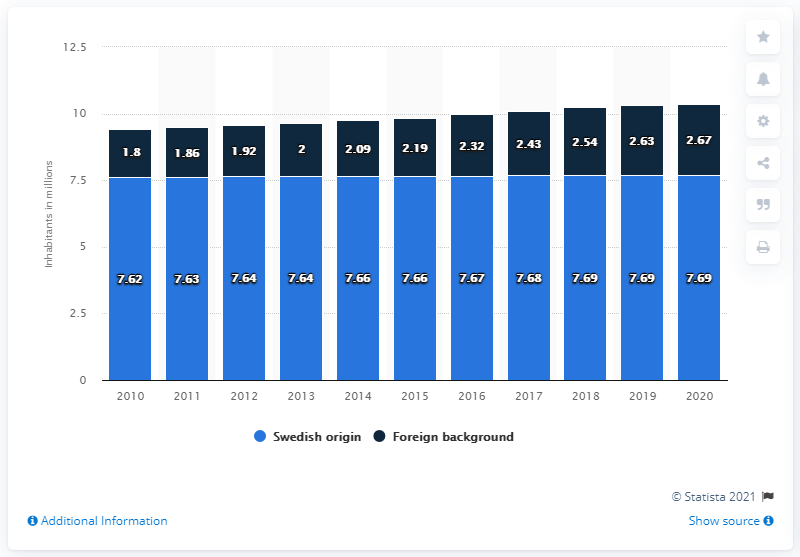Identify some key points in this picture. Approximately 7.69 million people in Sweden have a Swedish background. In Sweden, approximately 2.67% of the population has a foreign background. 